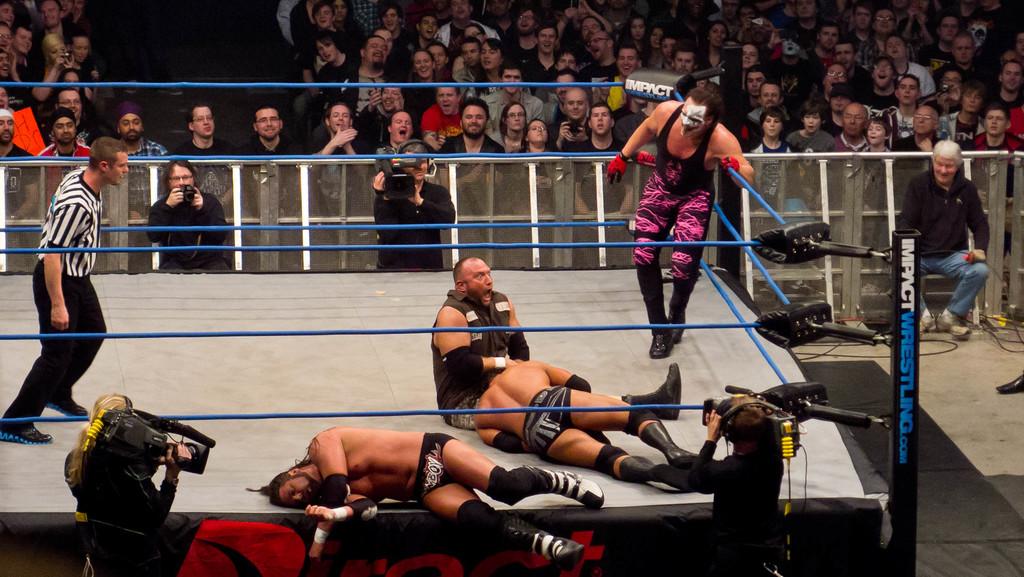What is the name of the advertiser seen on the pole in the bottom right?
Ensure brevity in your answer.  Impact wrestling. 